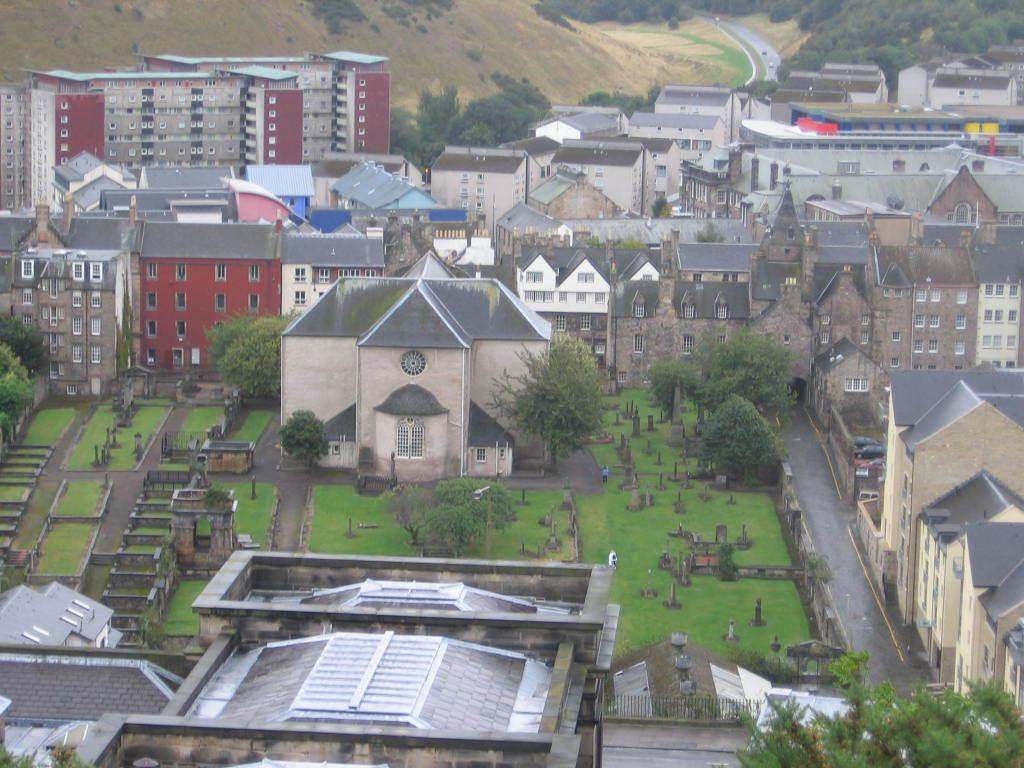What type of structures can be seen in the image? There are many buildings in the image. What can be seen on the ground in the image? The ground is visible in the image. What type of vegetation is present in the image? There are many trees in the image. What is located between the buildings in the image? There is a road between the buildings. What can be seen in the distance in the image? In the background, there are mountains. Are there any additional trees in the background of the image? Yes, there are additional trees in the background. What type of corn is growing on the side of the road in the image? There is no corn growing on the side of the road in the image. What type of arch can be seen in the image? There is no arch present in the image. 